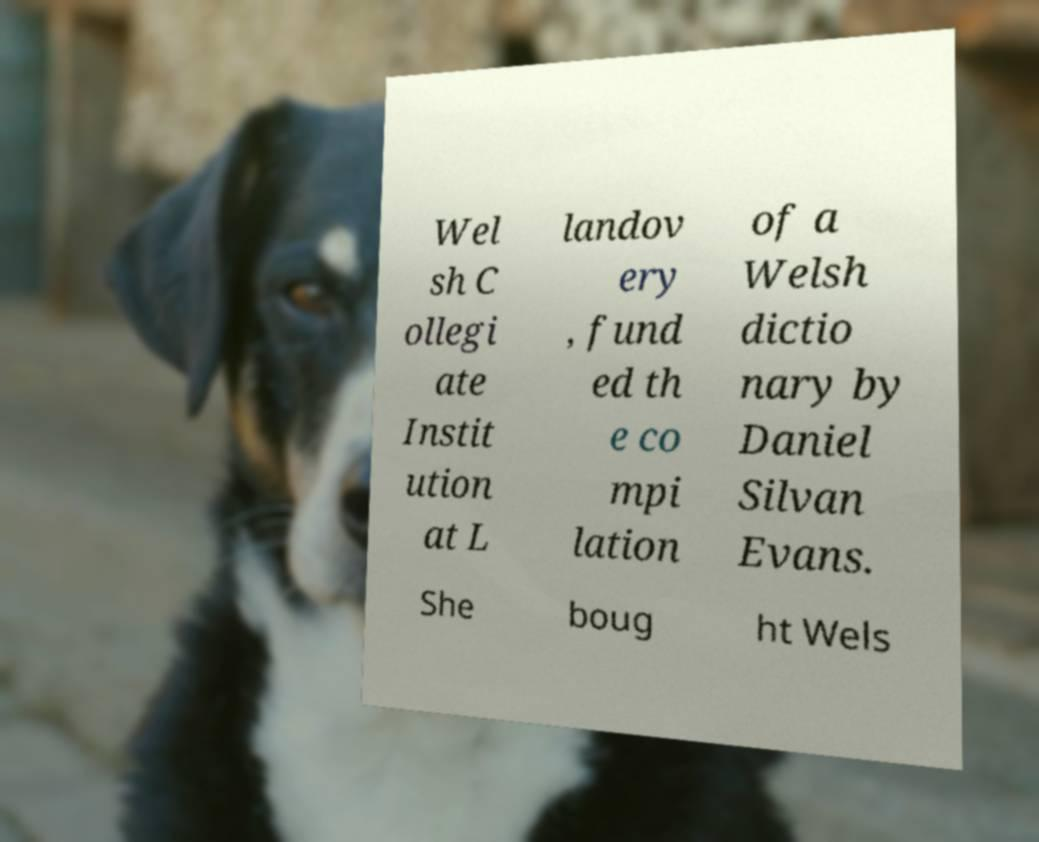There's text embedded in this image that I need extracted. Can you transcribe it verbatim? Wel sh C ollegi ate Instit ution at L landov ery , fund ed th e co mpi lation of a Welsh dictio nary by Daniel Silvan Evans. She boug ht Wels 